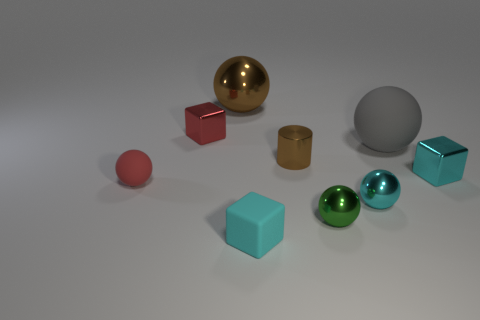Subtract all gray spheres. How many spheres are left? 4 Subtract 1 blocks. How many blocks are left? 2 Subtract all gray balls. How many balls are left? 4 Subtract all blue balls. Subtract all gray cylinders. How many balls are left? 5 Add 1 blue metallic cubes. How many objects exist? 10 Subtract all cubes. How many objects are left? 6 Add 7 blue cylinders. How many blue cylinders exist? 7 Subtract 0 yellow cylinders. How many objects are left? 9 Subtract all red blocks. Subtract all brown balls. How many objects are left? 7 Add 2 large spheres. How many large spheres are left? 4 